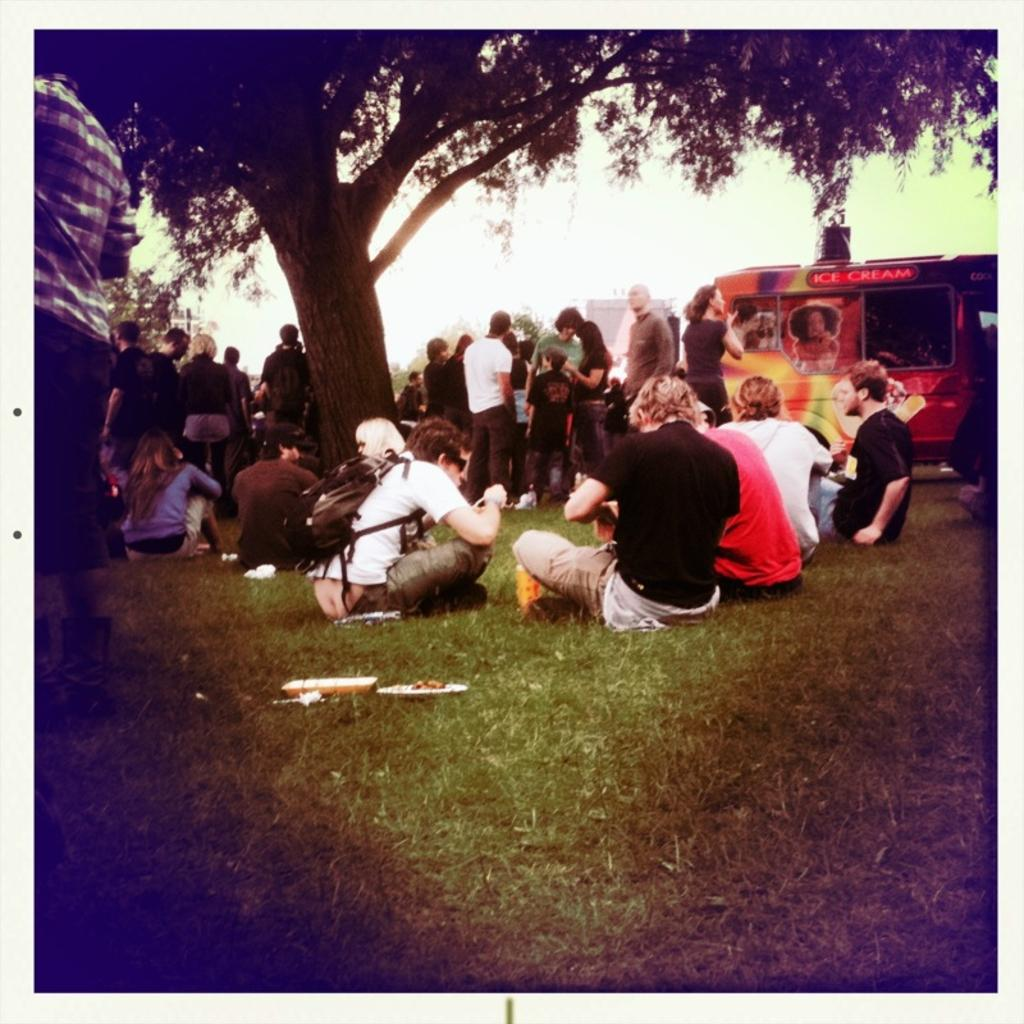How many people are in the image? There is a group of people in the image, but the exact number cannot be determined from the provided facts. What are some people doing in the image? Some people are seated on the grass, while others are standing. What can be seen in the background of the image? There is a vehicle, trees, and a building in the background of the image. What type of wax is being used by the people in the image? There is no indication in the image that wax is being used by anyone. What is the value of the hat worn by the person in the image? There is no hat visible in the image, so it is not possible to determine its value. 